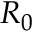<formula> <loc_0><loc_0><loc_500><loc_500>R _ { 0 }</formula> 